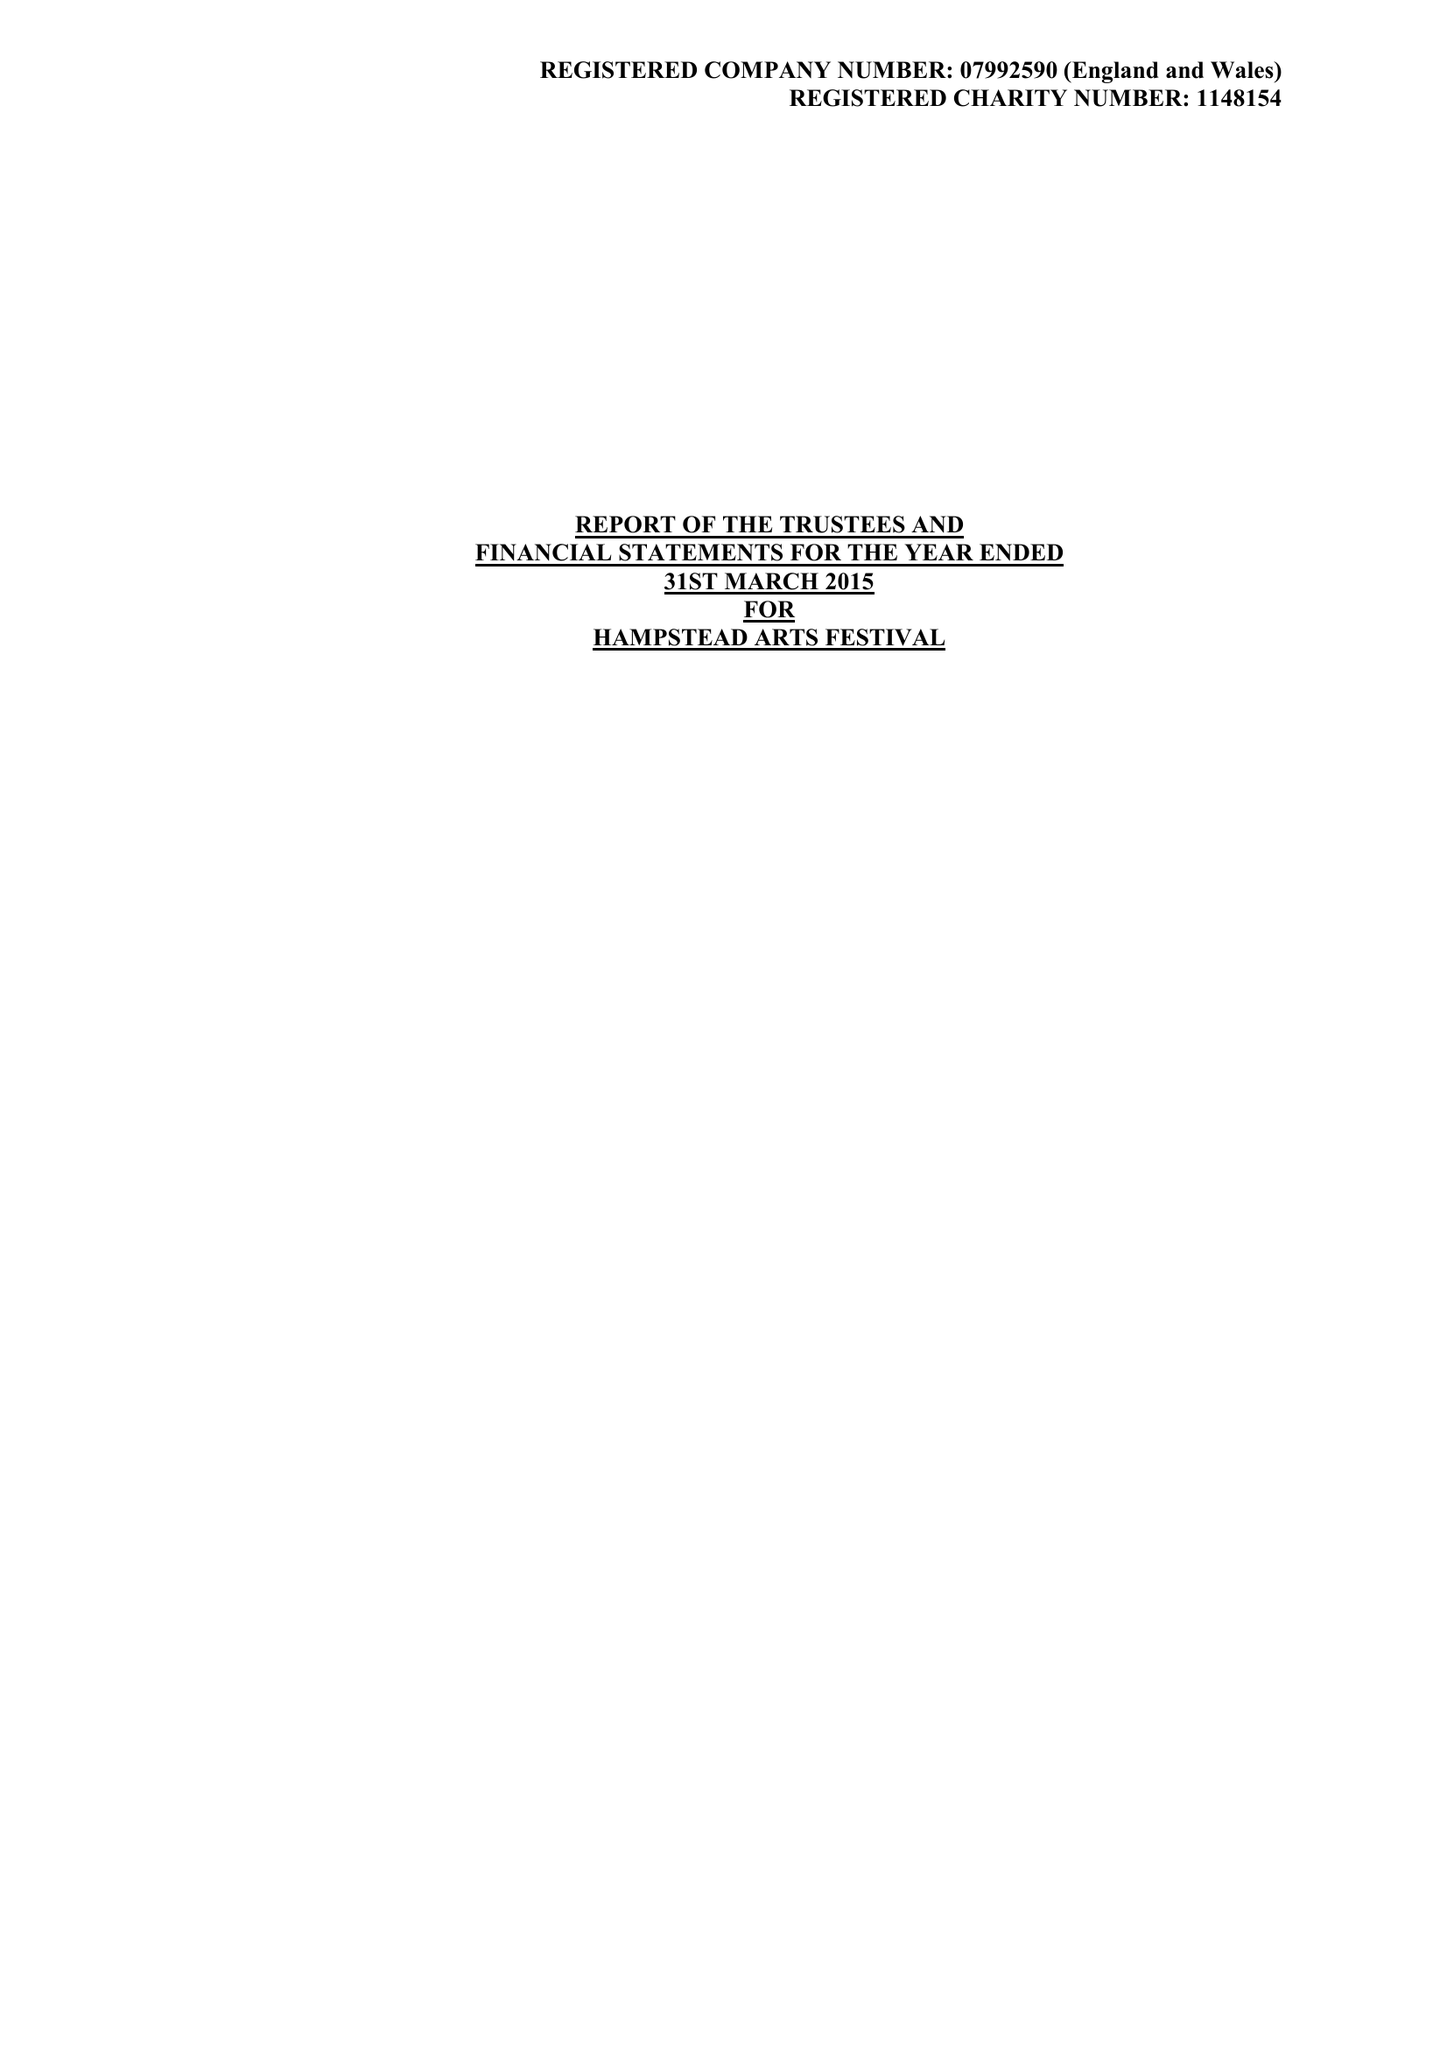What is the value for the income_annually_in_british_pounds?
Answer the question using a single word or phrase. 40118.00 